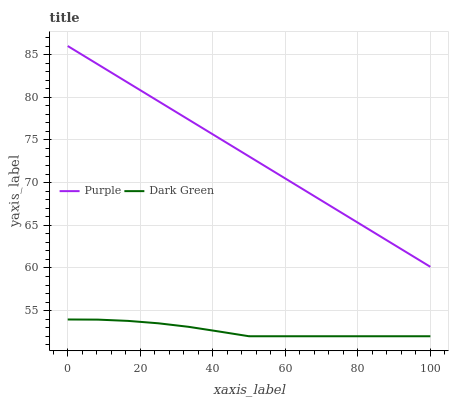Does Dark Green have the minimum area under the curve?
Answer yes or no. Yes. Does Purple have the maximum area under the curve?
Answer yes or no. Yes. Does Dark Green have the maximum area under the curve?
Answer yes or no. No. Is Purple the smoothest?
Answer yes or no. Yes. Is Dark Green the roughest?
Answer yes or no. Yes. Is Dark Green the smoothest?
Answer yes or no. No. Does Dark Green have the lowest value?
Answer yes or no. Yes. Does Purple have the highest value?
Answer yes or no. Yes. Does Dark Green have the highest value?
Answer yes or no. No. Is Dark Green less than Purple?
Answer yes or no. Yes. Is Purple greater than Dark Green?
Answer yes or no. Yes. Does Dark Green intersect Purple?
Answer yes or no. No. 